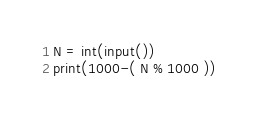<code> <loc_0><loc_0><loc_500><loc_500><_Python_>N = int(input())
print(1000-( N % 1000 ))
</code> 